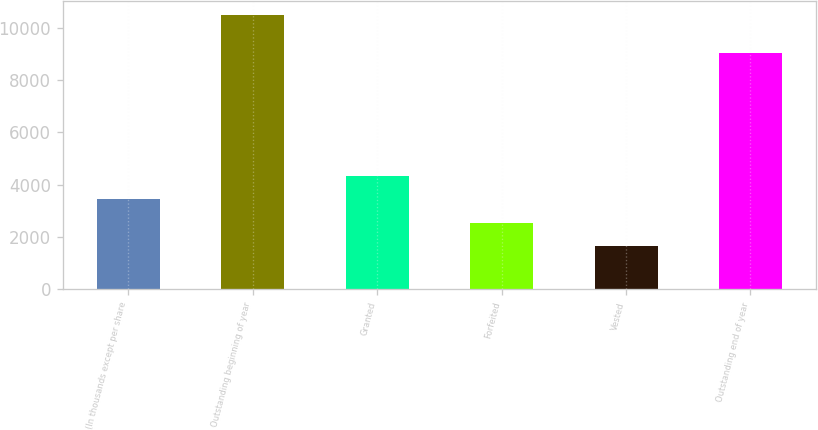Convert chart. <chart><loc_0><loc_0><loc_500><loc_500><bar_chart><fcel>(In thousands except per share<fcel>Outstanding beginning of year<fcel>Granted<fcel>Forfeited<fcel>Vested<fcel>Outstanding end of year<nl><fcel>3436.8<fcel>10488<fcel>4318.2<fcel>2555.4<fcel>1674<fcel>9020<nl></chart> 